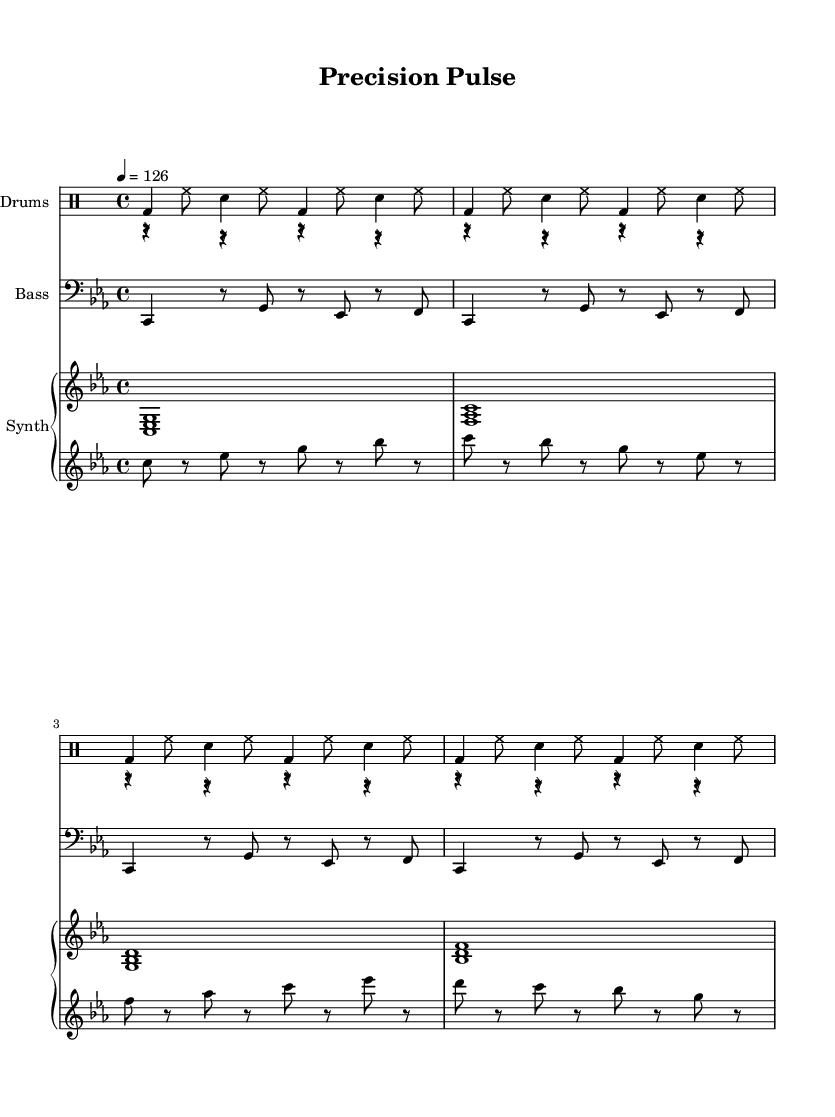What is the key signature of this music? The key signature in the score is C minor, indicated by the presence of three flats (B-flat, E-flat, and A-flat) on the staff.
Answer: C minor What is the time signature of this music? The time signature shown in the music is 4/4, which means there are four beats in each measure and a quarter note receives one beat.
Answer: 4/4 What is the tempo marking of this piece? The tempo marking is indicated as 4 = 126, meaning the quarter note has a speed of 126 beats per minute.
Answer: 126 How many measures are repeated for the kick pattern? The kick pattern is repeated for a total of four measures as indicated by the "\repeat unfold 4" command.
Answer: 4 What type of instrument primarily plays the kick pattern? The kick pattern is primarily played by the bass drum, which is indicated as "bd" in the drummode section.
Answer: Bass drum What is the characteristic note length for the lead synth pattern? The lead synth pattern consists of eighth notes, as indicated by their notation, which shows a rhythmic structure of alternating notes and rests in eighth note duration.
Answer: Eighth notes What sound design technique is emphasized in this minimal tech house piece? The piece focuses on precise automation in sound design, which is reflected in the varied rhythmic and note patterns, creating a dynamic listening experience typical of minimal tech house tracks.
Answer: Precise automation 